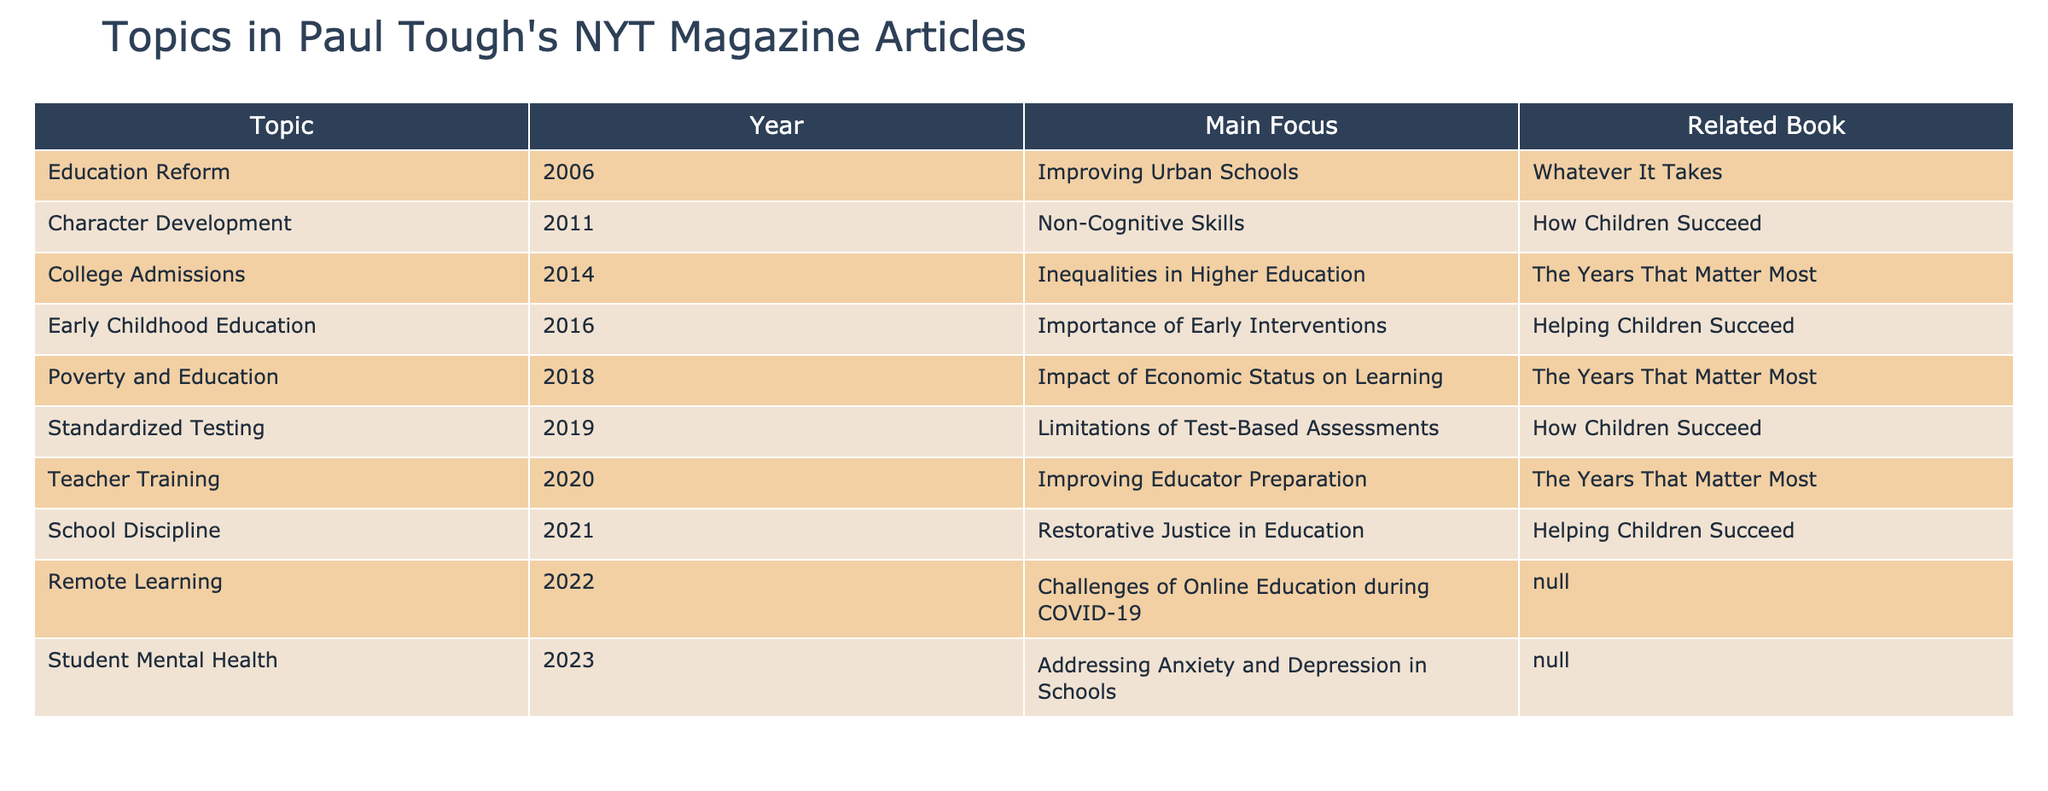What topic was covered in 2011? Referring to the table, the row for the year 2011 shows that the topic covered was "Character Development."
Answer: Character Development Which book is related to the topic of Poverty and Education? Looking at the table, the row for "Poverty and Education" indicates that it is related to the book "The Years That Matter Most."
Answer: The Years That Matter Most In which year did Paul Tough write about Remote Learning? The table shows that the topic "Remote Learning" was covered in the year 2022.
Answer: 2022 How many different topics are associated with books published by Paul Tough? Counting the unique topics listed in the "Related Book" column, there are 7 distinct books, indicating several topics are associated with books.
Answer: 7 Did Paul Tough write about Standardized Testing before 2019? The table shows that the topic "Standardized Testing" was covered in 2019, so it was not written about before that year.
Answer: No What is the main focus of the article on Teacher Training? The table states that the main focus of the article on "Teacher Training" is improving educator preparation.
Answer: Improving educator preparation Which topics discussed by Paul Tough are related to mental health? The table shows only one topic directly addressing mental health, which is "Student Mental Health" covered in 2023.
Answer: Student Mental Health How many years had passed between the articles on College Admissions and Early Childhood Education? The article on College Admissions was covered in 2014, and Early Childhood Education was in 2016. Therefore, the difference is 2016 - 2014 = 2 years.
Answer: 2 years What percentage of the articles focus on education reform-related topics? There are 8 topics listed in total, of which 5 (Education Reform, Early Childhood Education, Teacher Training, School Discipline, Poverty and Education) are directly related to education reform, making it 5/8 = 62.5%.
Answer: 62.5% 